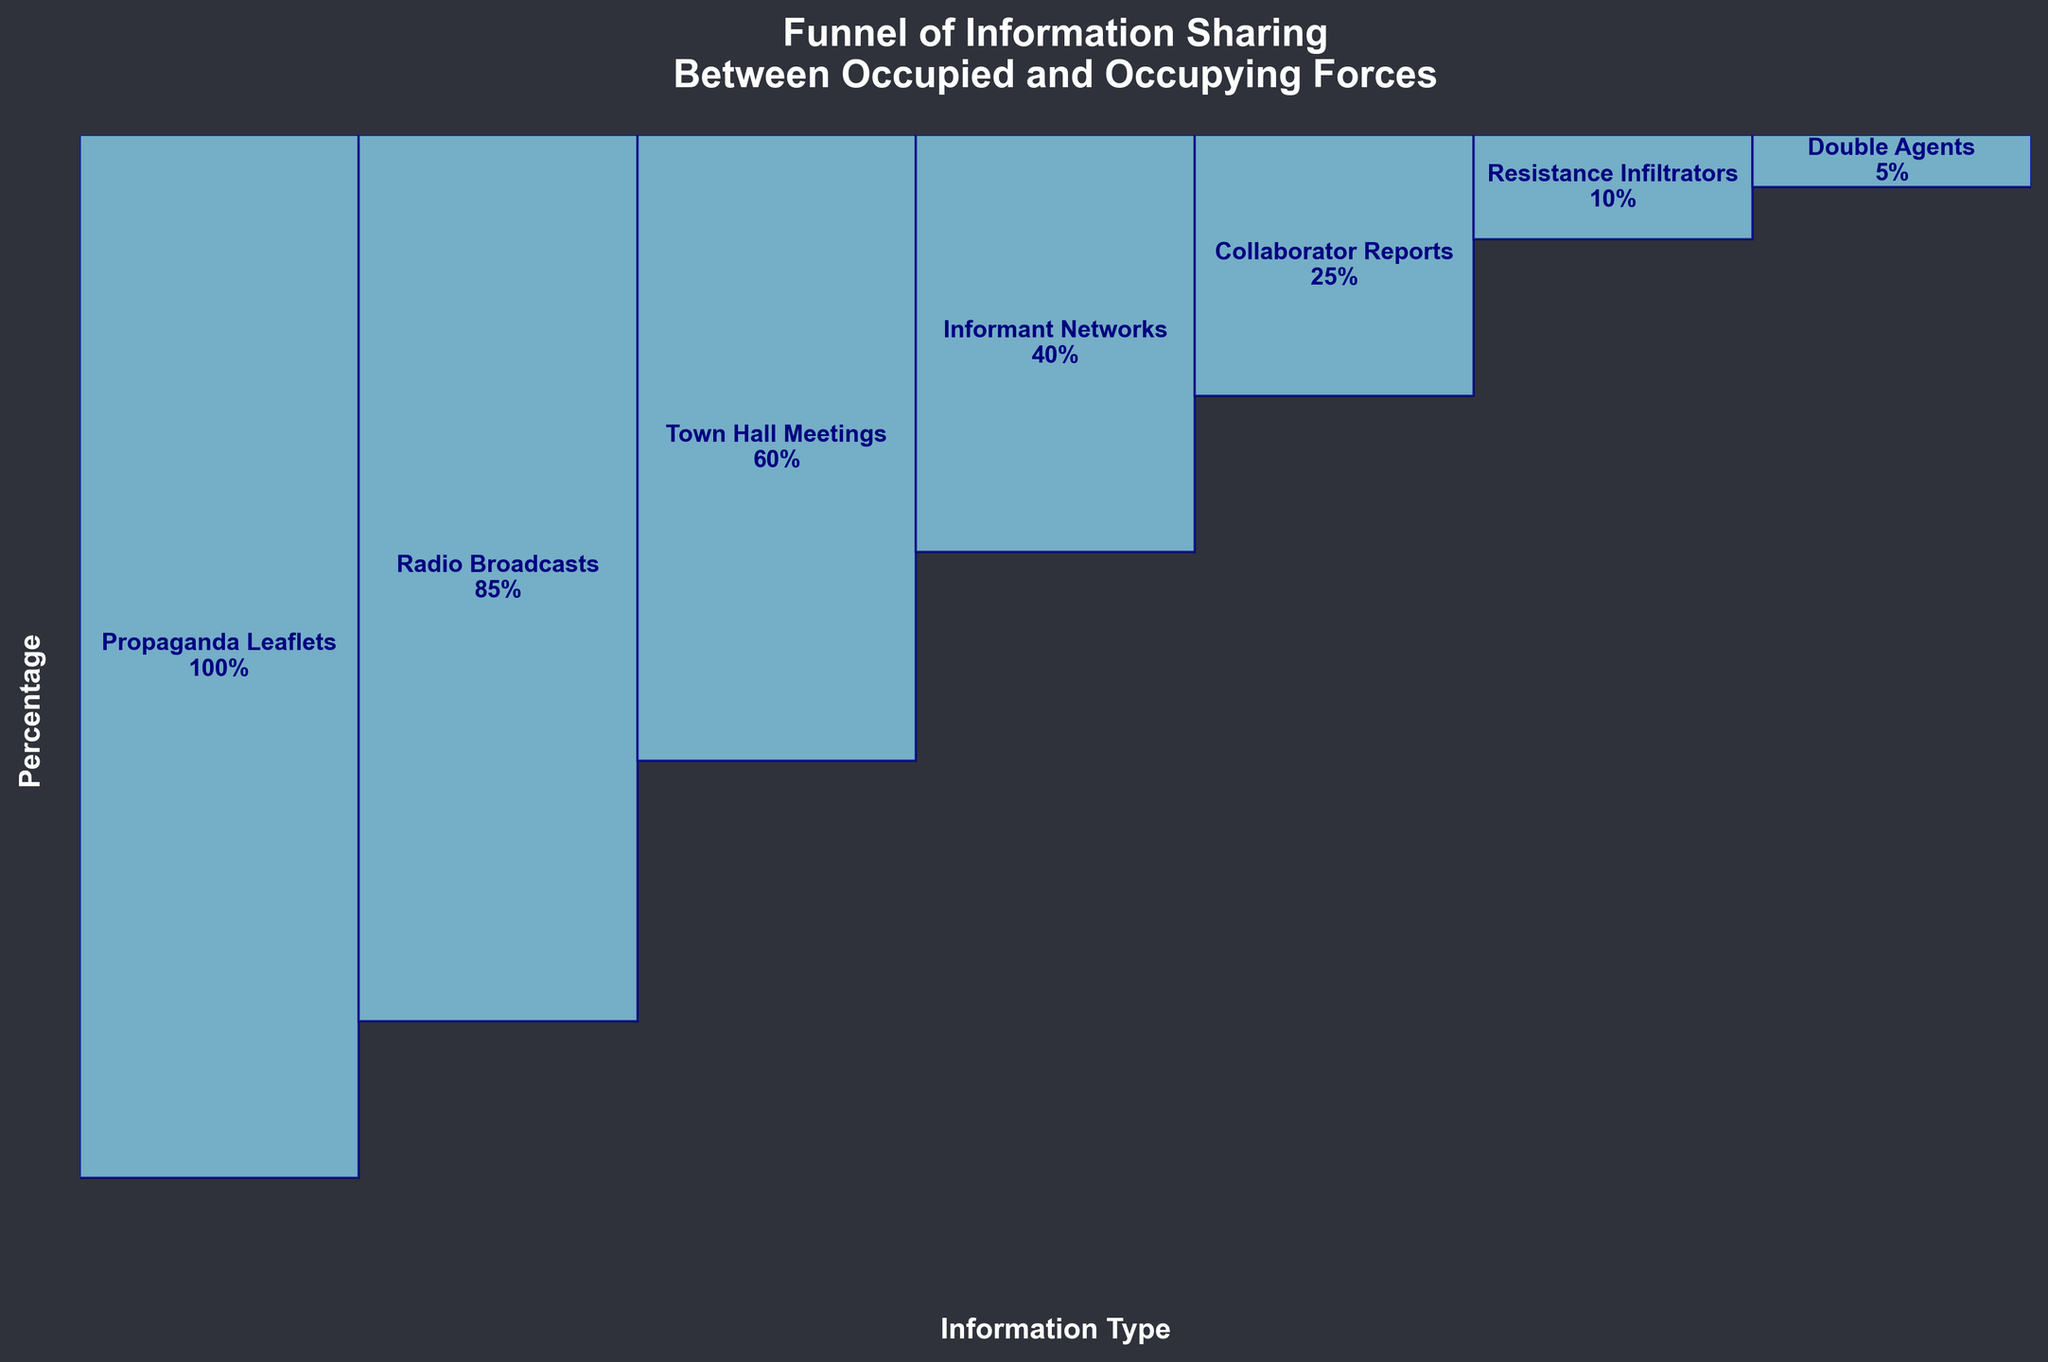What is the title of the figure? The title is usually displayed at the top of the figure. In this case, the title is "Funnel of Information Sharing\nBetween Occupied and Occupying Forces". This helps in understanding the context of the data presented.
Answer: Funnel of Information Sharing\nBetween Occupied and Occupying Forces How many stages are shown in the funnel chart? Count the number of bars or labels in the chart to determine the number of stages. Each stage represents a type of information shared.
Answer: 7 Which stage has the highest percentage of information sharing? Identify the bar with the greatest height, which corresponds to the highest percentage. The label associated with this bar indicates the stage.
Answer: General Public Information What is the difference in percentage between Local News and Announcements and Classified Military Plans? Look at the percentage values for the two stages: Local News and Announcements (85%) and Classified Military Plans (10%). Subtract the smaller number from the larger one to find the difference.
Answer: 75% What is the average percentage of information shared across all stages? Add up all the percentage values: 100 + 85 + 60 + 40 + 25 + 10 + 5. Then divide by the number of stages, which is 7.
Answer: 46.43% Which stages show a percentage below the average percentage of information sharing? First, calculate the average percentage (46.43%). Then, compare each stage's percentage with the average to determine which are below this value. Stages with less than 46.43% are Low-Level Intelligence, Mid-Level Strategic Info, Classified Military Plans, and Top Secret Operations.
Answer: Low-Level Intelligence, Mid-Level Strategic Info, Classified Military Plans, Top Secret Operations How does the percentage of information shared at Civilian-Military Interactions compare to Low-Level Intelligence? Find the percentage values for Civilian-Military Interactions (60%) and Low-Level Intelligence (40%). Compare the two to determine if one is higher or lower.
Answer: Civilian-Military Interactions is higher by 20% By what percentage does the information sharing drop from Civilian-Military Interactions to Mid-Level Strategic Info? Look at the percentage values for the two stages: Civilian-Military Interactions (60%) and Mid-Level Strategic Info (25%). Subtract the smaller value from the larger to find the drop.
Answer: 35% Which stage has the lowest percentage of information sharing? Identify the bar with the shortest height, which corresponds to the lowest percentage. The label associated with this bar indicates the stage.
Answer: Top Secret Operations 